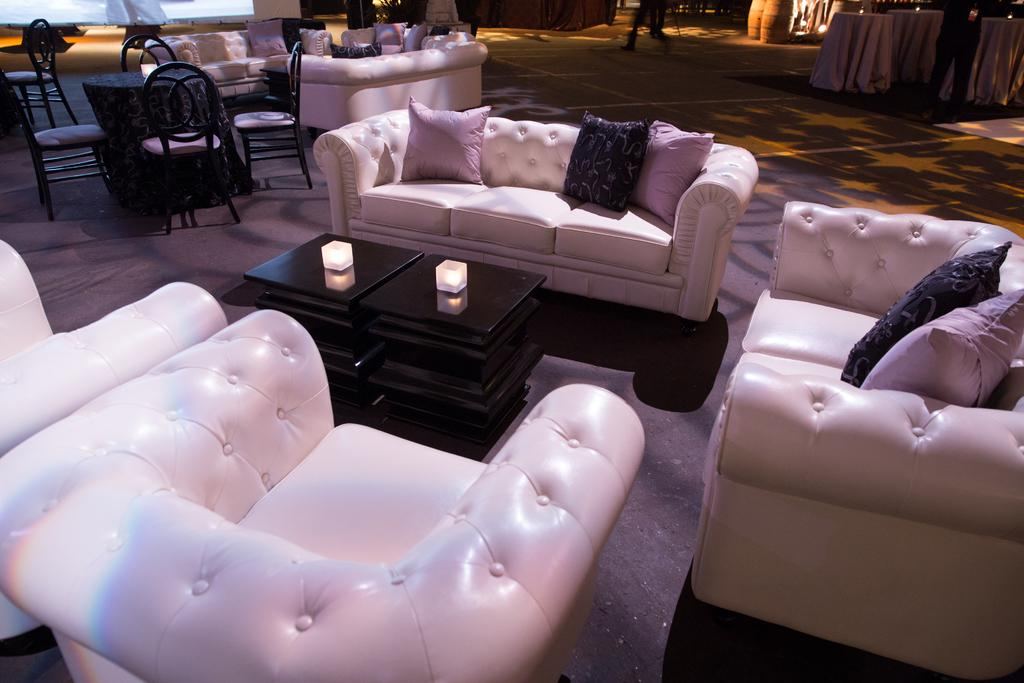What type of room is depicted in the image? The image shows the inside view of a hall. What type of furniture is present in the hall? There are sofas in the hall. Are there any additional items on the sofas? Yes, there are pillows on the sofas. What other piece of furniture can be seen in the hall? There is a table in the hall. How is the hall illuminated? There are lights in the hall. How many cattle are present in the hall in the image? There are no cattle present in the hall in the image. What type of heat source can be seen in the image? There is no heat source visible in the image. 